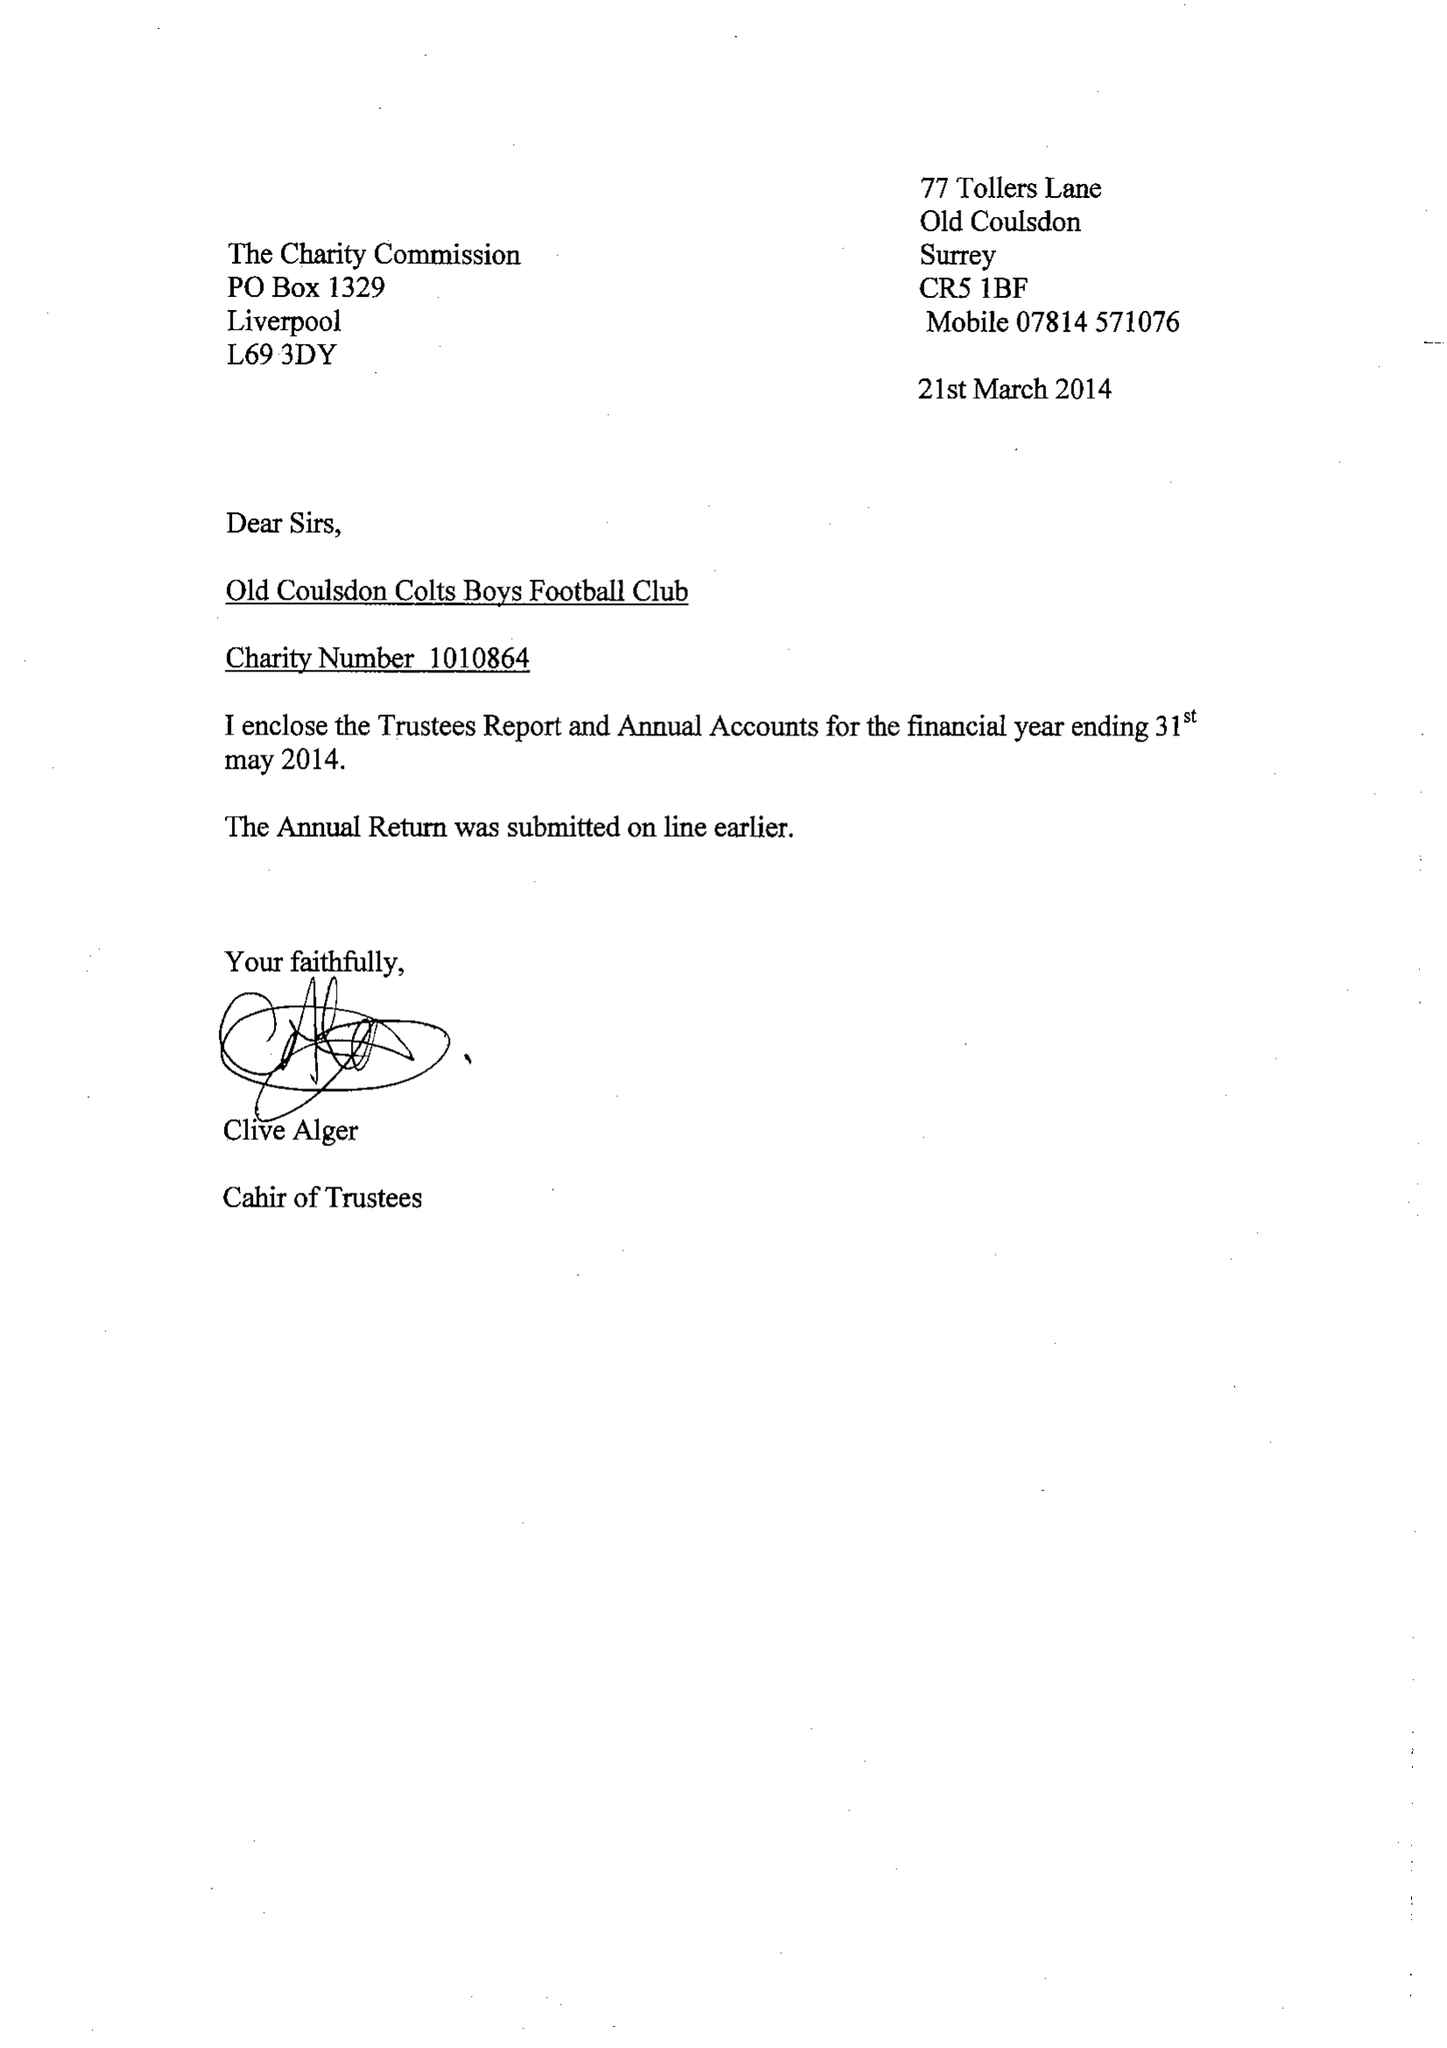What is the value for the income_annually_in_british_pounds?
Answer the question using a single word or phrase. 72461.00 